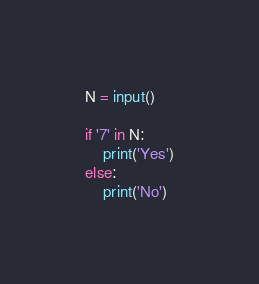<code> <loc_0><loc_0><loc_500><loc_500><_Python_>N = input()

if '7' in N:
    print('Yes')
else:
    print('No')</code> 